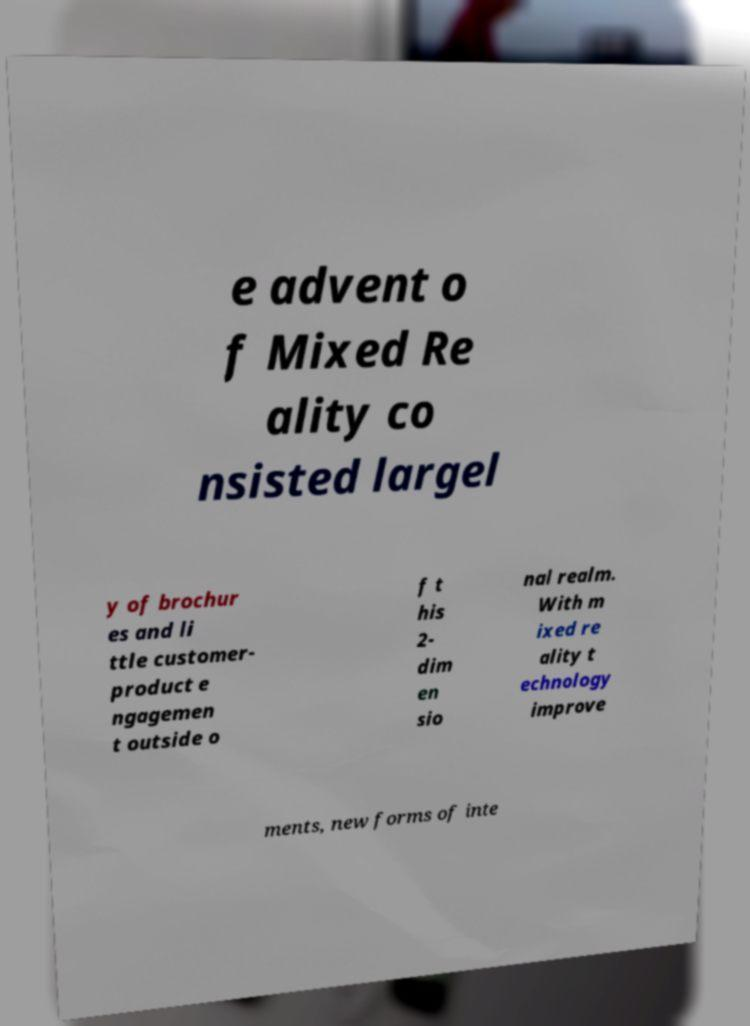Could you extract and type out the text from this image? e advent o f Mixed Re ality co nsisted largel y of brochur es and li ttle customer- product e ngagemen t outside o f t his 2- dim en sio nal realm. With m ixed re ality t echnology improve ments, new forms of inte 